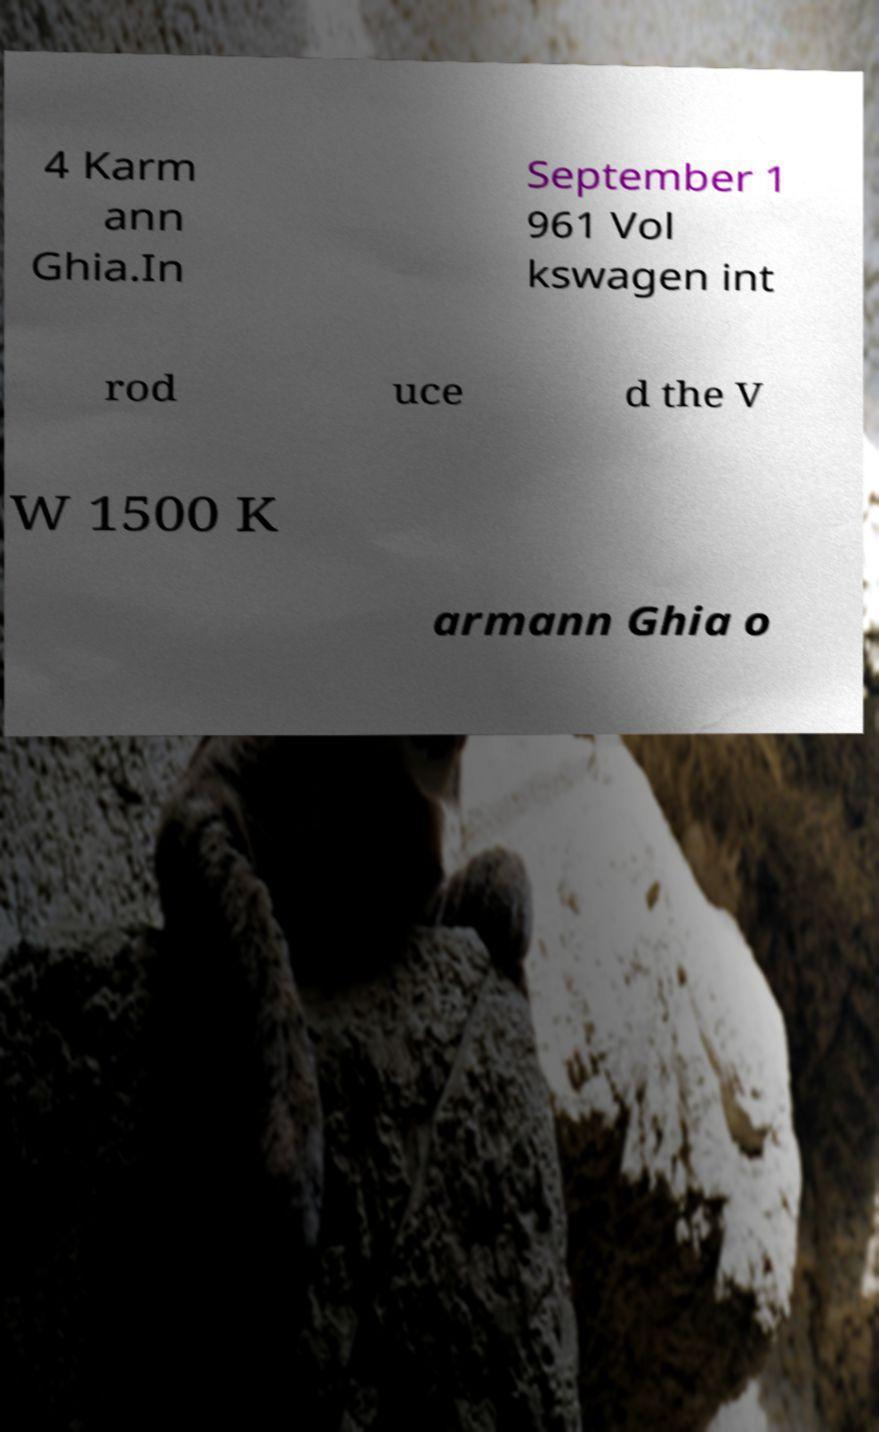I need the written content from this picture converted into text. Can you do that? 4 Karm ann Ghia.In September 1 961 Vol kswagen int rod uce d the V W 1500 K armann Ghia o 